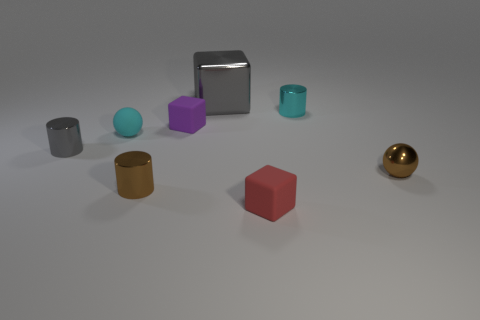Subtract all small rubber cubes. How many cubes are left? 1 Add 2 big metallic blocks. How many objects exist? 10 Subtract all purple blocks. How many blocks are left? 2 Subtract all spheres. How many objects are left? 6 Add 7 tiny brown metal spheres. How many tiny brown metal spheres are left? 8 Add 8 tiny metallic spheres. How many tiny metallic spheres exist? 9 Subtract 1 gray cylinders. How many objects are left? 7 Subtract 1 balls. How many balls are left? 1 Subtract all gray spheres. Subtract all yellow blocks. How many spheres are left? 2 Subtract all small objects. Subtract all large yellow cylinders. How many objects are left? 1 